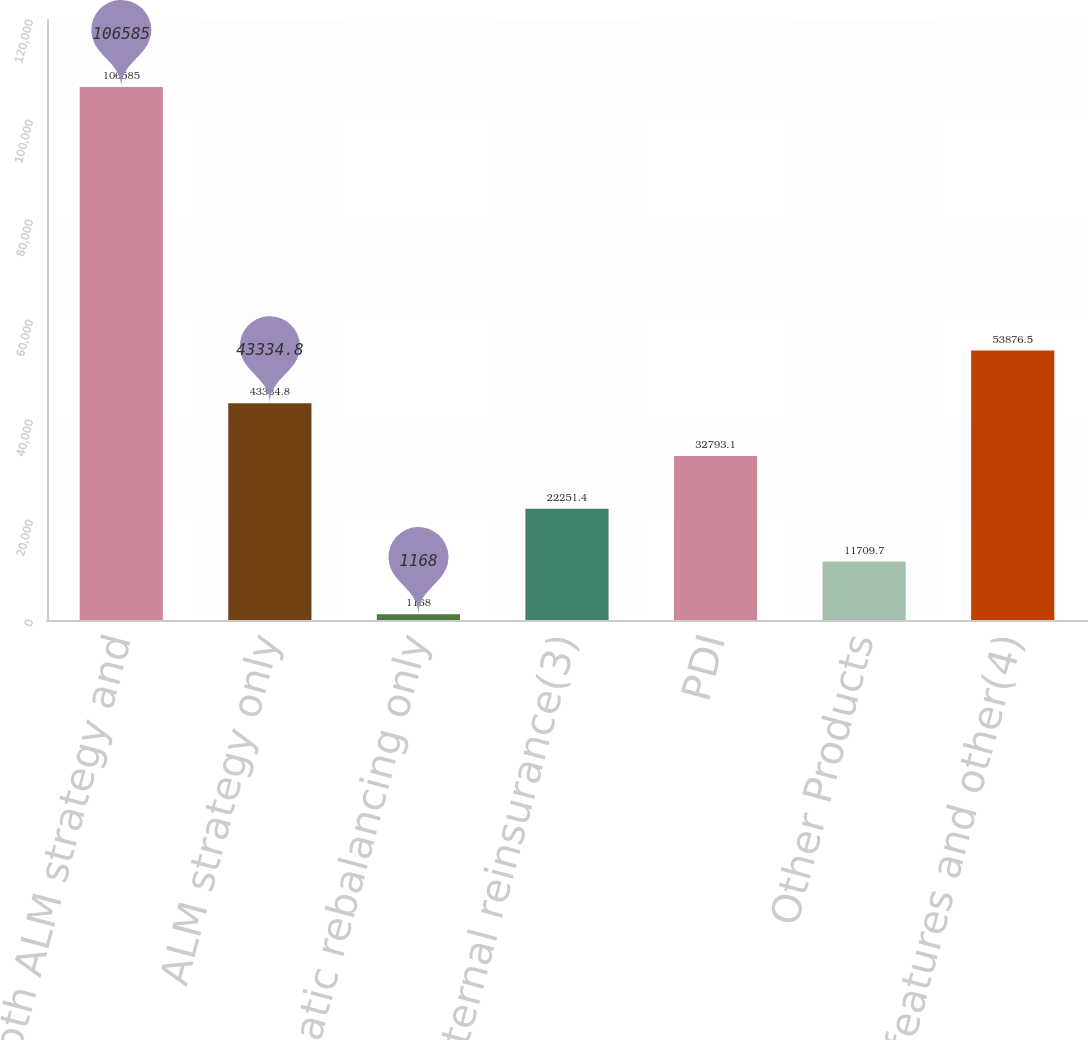<chart> <loc_0><loc_0><loc_500><loc_500><bar_chart><fcel>Both ALM strategy and<fcel>ALM strategy only<fcel>Automatic rebalancing only<fcel>External reinsurance(3)<fcel>PDI<fcel>Other Products<fcel>GMDB features and other(4)<nl><fcel>106585<fcel>43334.8<fcel>1168<fcel>22251.4<fcel>32793.1<fcel>11709.7<fcel>53876.5<nl></chart> 